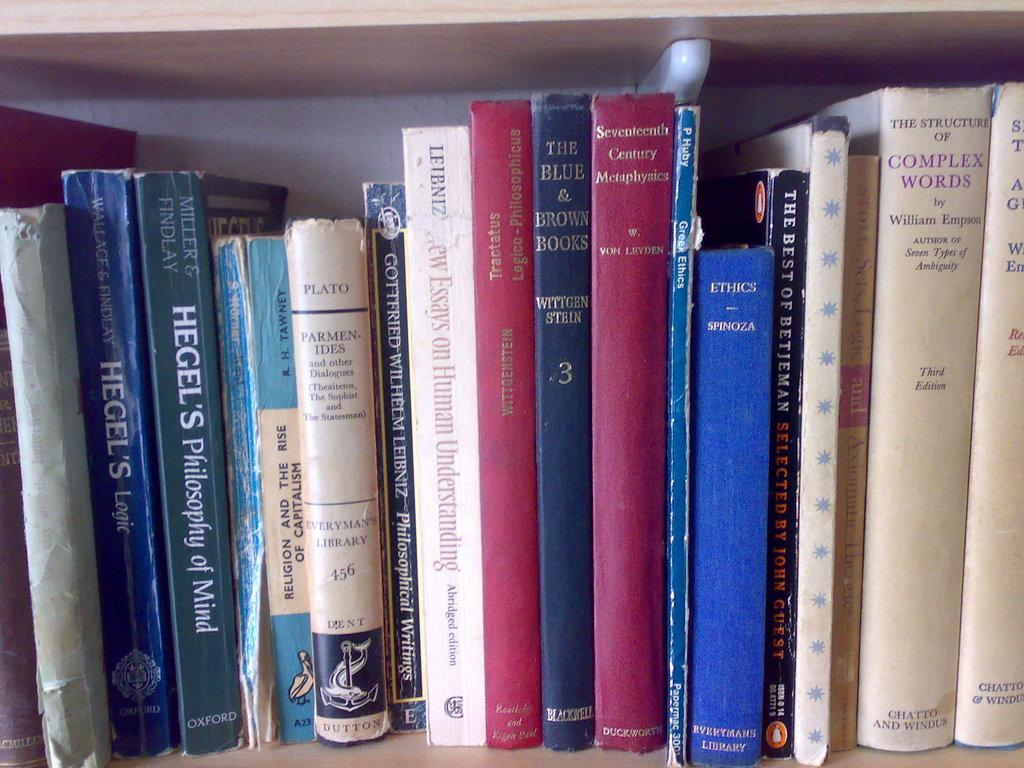<image>
Present a compact description of the photo's key features. The book Hegel's Philosophy of Mind sits on a shelf with many other old books. 